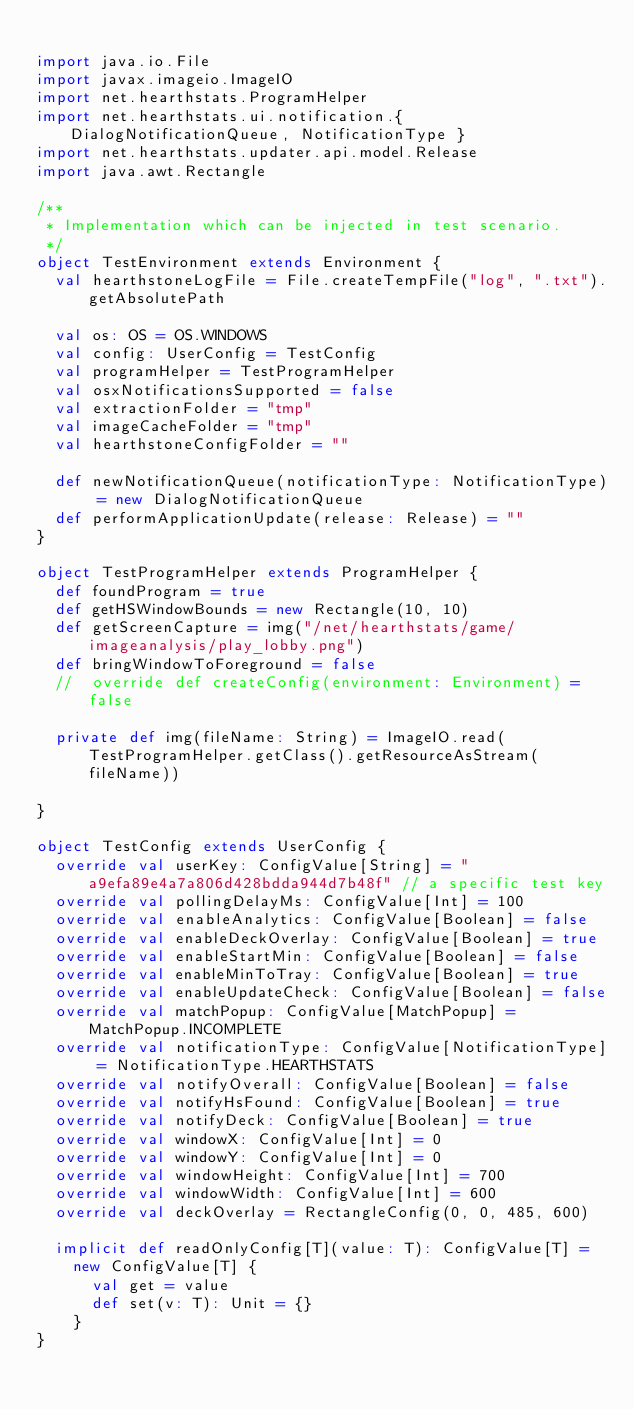<code> <loc_0><loc_0><loc_500><loc_500><_Scala_>
import java.io.File
import javax.imageio.ImageIO
import net.hearthstats.ProgramHelper
import net.hearthstats.ui.notification.{ DialogNotificationQueue, NotificationType }
import net.hearthstats.updater.api.model.Release
import java.awt.Rectangle

/**
 * Implementation which can be injected in test scenario.
 */
object TestEnvironment extends Environment {
  val hearthstoneLogFile = File.createTempFile("log", ".txt").getAbsolutePath

  val os: OS = OS.WINDOWS
  val config: UserConfig = TestConfig
  val programHelper = TestProgramHelper
  val osxNotificationsSupported = false
  val extractionFolder = "tmp"
  val imageCacheFolder = "tmp"
  val hearthstoneConfigFolder = ""

  def newNotificationQueue(notificationType: NotificationType) = new DialogNotificationQueue
  def performApplicationUpdate(release: Release) = ""
}

object TestProgramHelper extends ProgramHelper {
  def foundProgram = true
  def getHSWindowBounds = new Rectangle(10, 10)
  def getScreenCapture = img("/net/hearthstats/game/imageanalysis/play_lobby.png")
  def bringWindowToForeground = false
  //  override def createConfig(environment: Environment) = false

  private def img(fileName: String) = ImageIO.read(TestProgramHelper.getClass().getResourceAsStream(fileName))

}

object TestConfig extends UserConfig {
  override val userKey: ConfigValue[String] = "a9efa89e4a7a806d428bdda944d7b48f" // a specific test key
  override val pollingDelayMs: ConfigValue[Int] = 100
  override val enableAnalytics: ConfigValue[Boolean] = false
  override val enableDeckOverlay: ConfigValue[Boolean] = true
  override val enableStartMin: ConfigValue[Boolean] = false
  override val enableMinToTray: ConfigValue[Boolean] = true
  override val enableUpdateCheck: ConfigValue[Boolean] = false
  override val matchPopup: ConfigValue[MatchPopup] = MatchPopup.INCOMPLETE
  override val notificationType: ConfigValue[NotificationType] = NotificationType.HEARTHSTATS
  override val notifyOverall: ConfigValue[Boolean] = false
  override val notifyHsFound: ConfigValue[Boolean] = true
  override val notifyDeck: ConfigValue[Boolean] = true
  override val windowX: ConfigValue[Int] = 0
  override val windowY: ConfigValue[Int] = 0
  override val windowHeight: ConfigValue[Int] = 700
  override val windowWidth: ConfigValue[Int] = 600
  override val deckOverlay = RectangleConfig(0, 0, 485, 600)

  implicit def readOnlyConfig[T](value: T): ConfigValue[T] =
    new ConfigValue[T] {
      val get = value
      def set(v: T): Unit = {}
    }
}</code> 